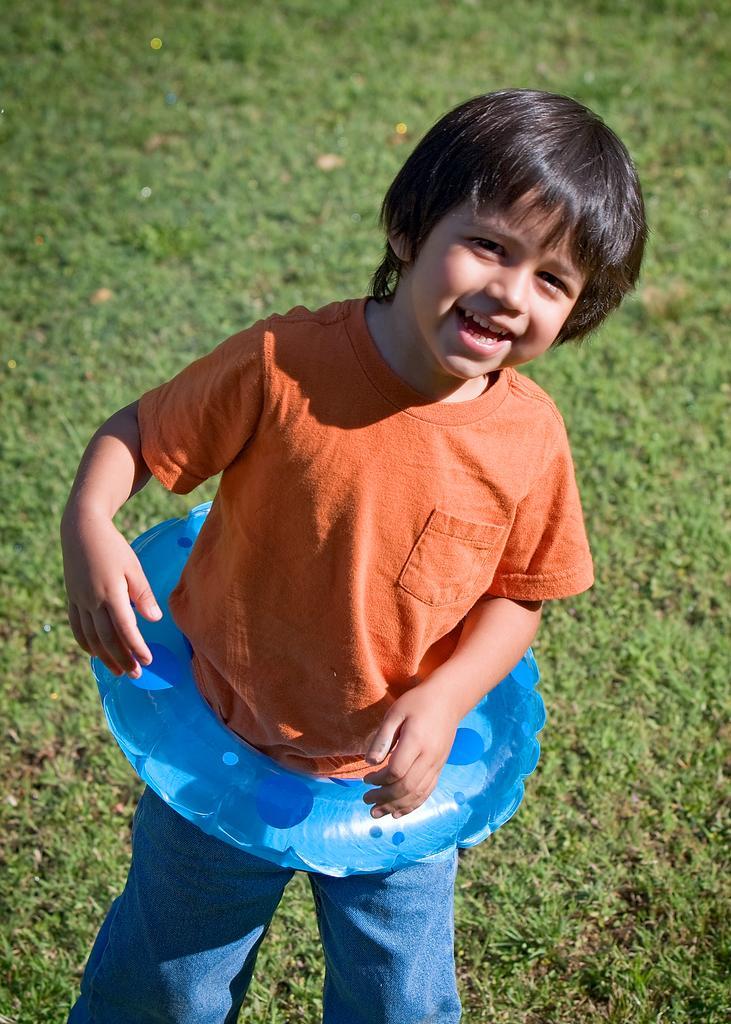Can you describe this image briefly? In this image we can see a kid wearing a tube, is standing and posing for a picture, there is grass in the background. 